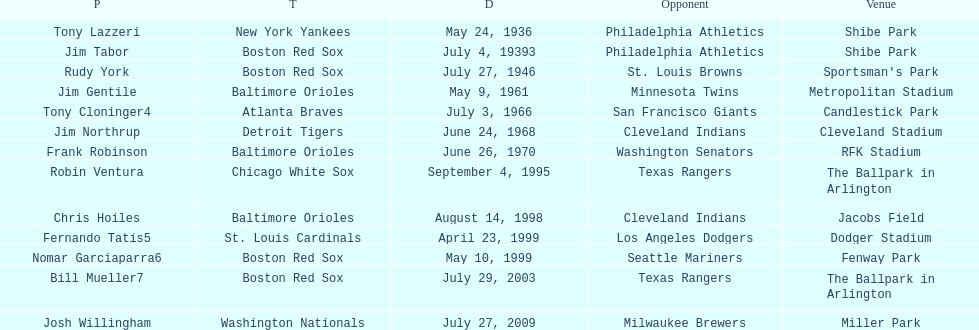What is the name of the player for the new york yankees in 1936? Tony Lazzeri. 